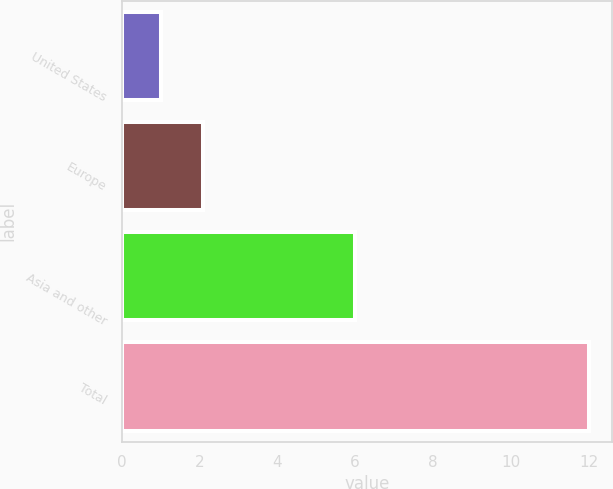Convert chart. <chart><loc_0><loc_0><loc_500><loc_500><bar_chart><fcel>United States<fcel>Europe<fcel>Asia and other<fcel>Total<nl><fcel>1<fcel>2.1<fcel>6<fcel>12<nl></chart> 